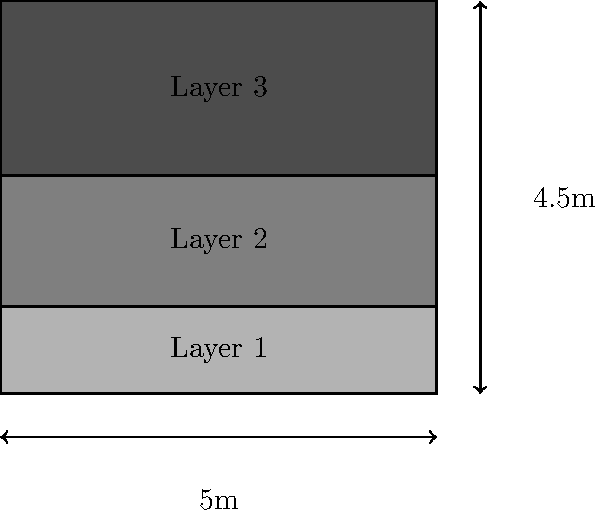Based on the partial remains of a Renaissance tiered garden structure shown in the diagram, estimate the total volume of soil used in all three layers. The structure is 5 meters wide and 4.5 meters tall. Layer 1 (bottom) is 1 meter deep, Layer 2 is 1.5 meters deep, and Layer 3 (top) is 2 meters deep. Assume the structure is 10 meters long. To calculate the total volume of soil, we need to follow these steps:

1. Calculate the volume of each layer:
   - Volume = length × width × depth
   - Layer 1: $V_1 = 10\text{ m} \times 5\text{ m} \times 1\text{ m} = 50\text{ m}^3$
   - Layer 2: $V_2 = 10\text{ m} \times 5\text{ m} \times 1.5\text{ m} = 75\text{ m}^3$
   - Layer 3: $V_3 = 10\text{ m} \times 5\text{ m} \times 2\text{ m} = 100\text{ m}^3$

2. Sum up the volumes of all three layers:
   $V_{\text{total}} = V_1 + V_2 + V_3 = 50\text{ m}^3 + 75\text{ m}^3 + 100\text{ m}^3 = 225\text{ m}^3$

Therefore, the total volume of soil used in all three layers is 225 cubic meters.
Answer: 225 m³ 